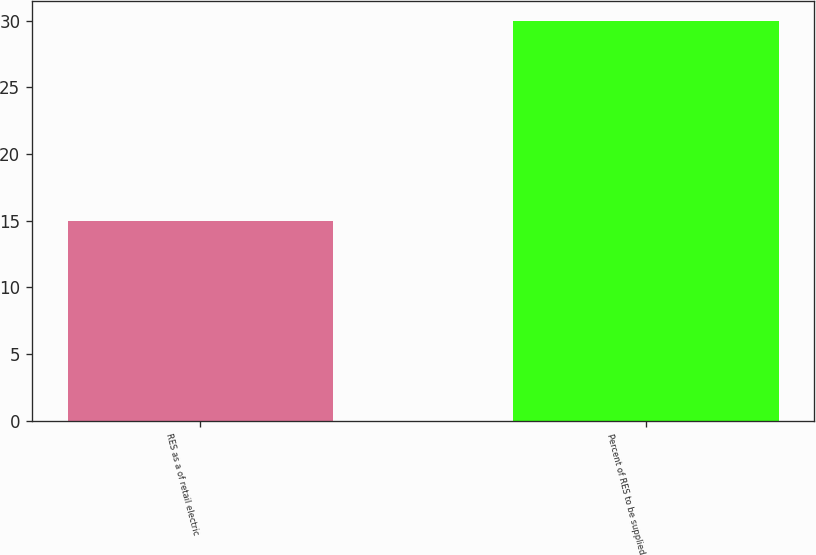<chart> <loc_0><loc_0><loc_500><loc_500><bar_chart><fcel>RES as a of retail electric<fcel>Percent of RES to be supplied<nl><fcel>15<fcel>30<nl></chart> 